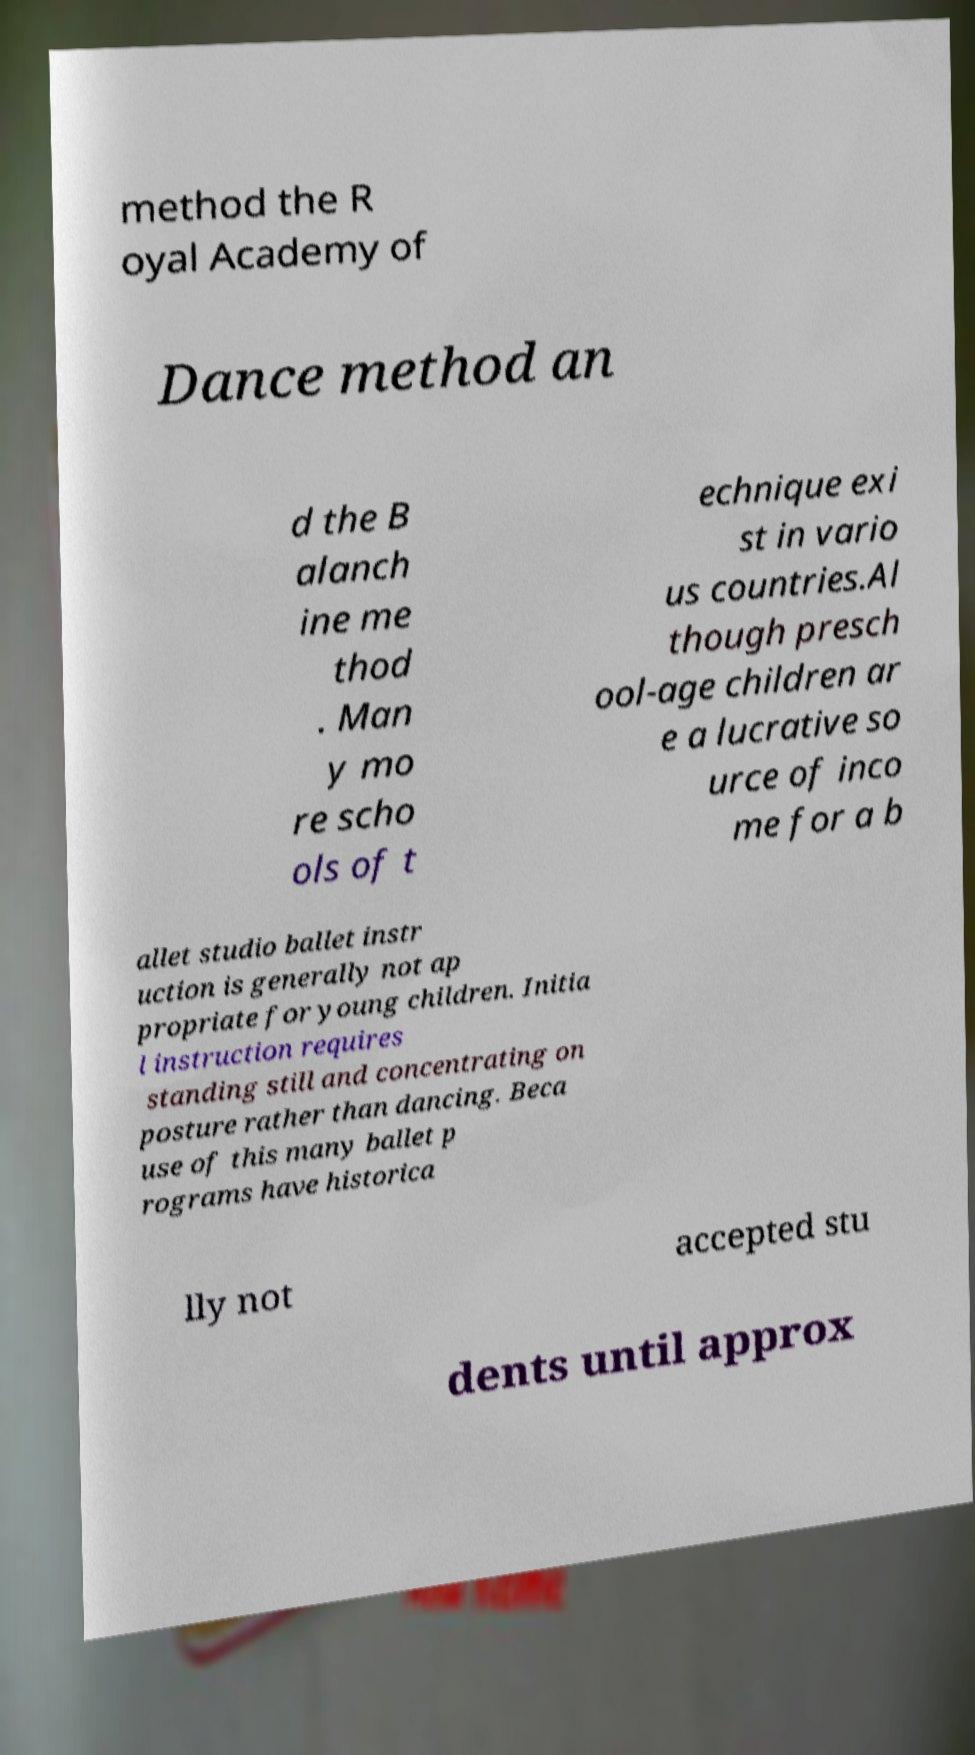Can you accurately transcribe the text from the provided image for me? method the R oyal Academy of Dance method an d the B alanch ine me thod . Man y mo re scho ols of t echnique exi st in vario us countries.Al though presch ool-age children ar e a lucrative so urce of inco me for a b allet studio ballet instr uction is generally not ap propriate for young children. Initia l instruction requires standing still and concentrating on posture rather than dancing. Beca use of this many ballet p rograms have historica lly not accepted stu dents until approx 